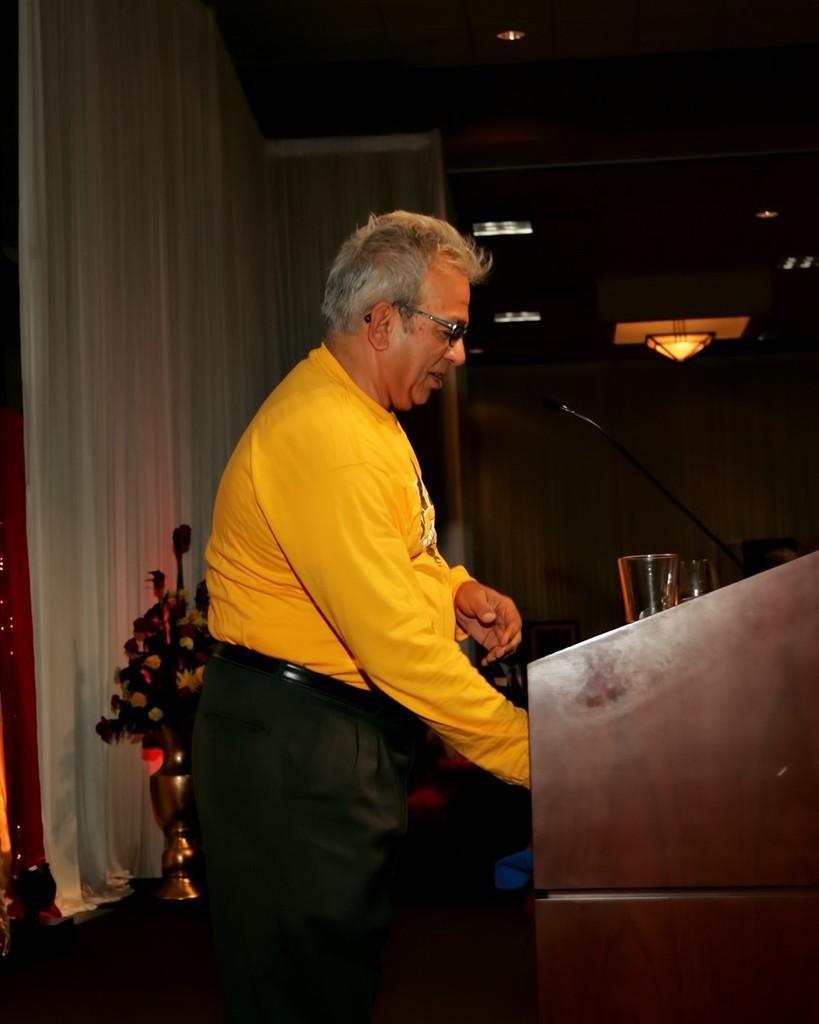Please provide a concise description of this image. On the left side, there is a person in a yellow color t-shirt, smiling and standing in front of a wooden stand, on which there are two glasses and a microphone arranged. In the background, there is a flower vase, there is a curtain and other objects. 